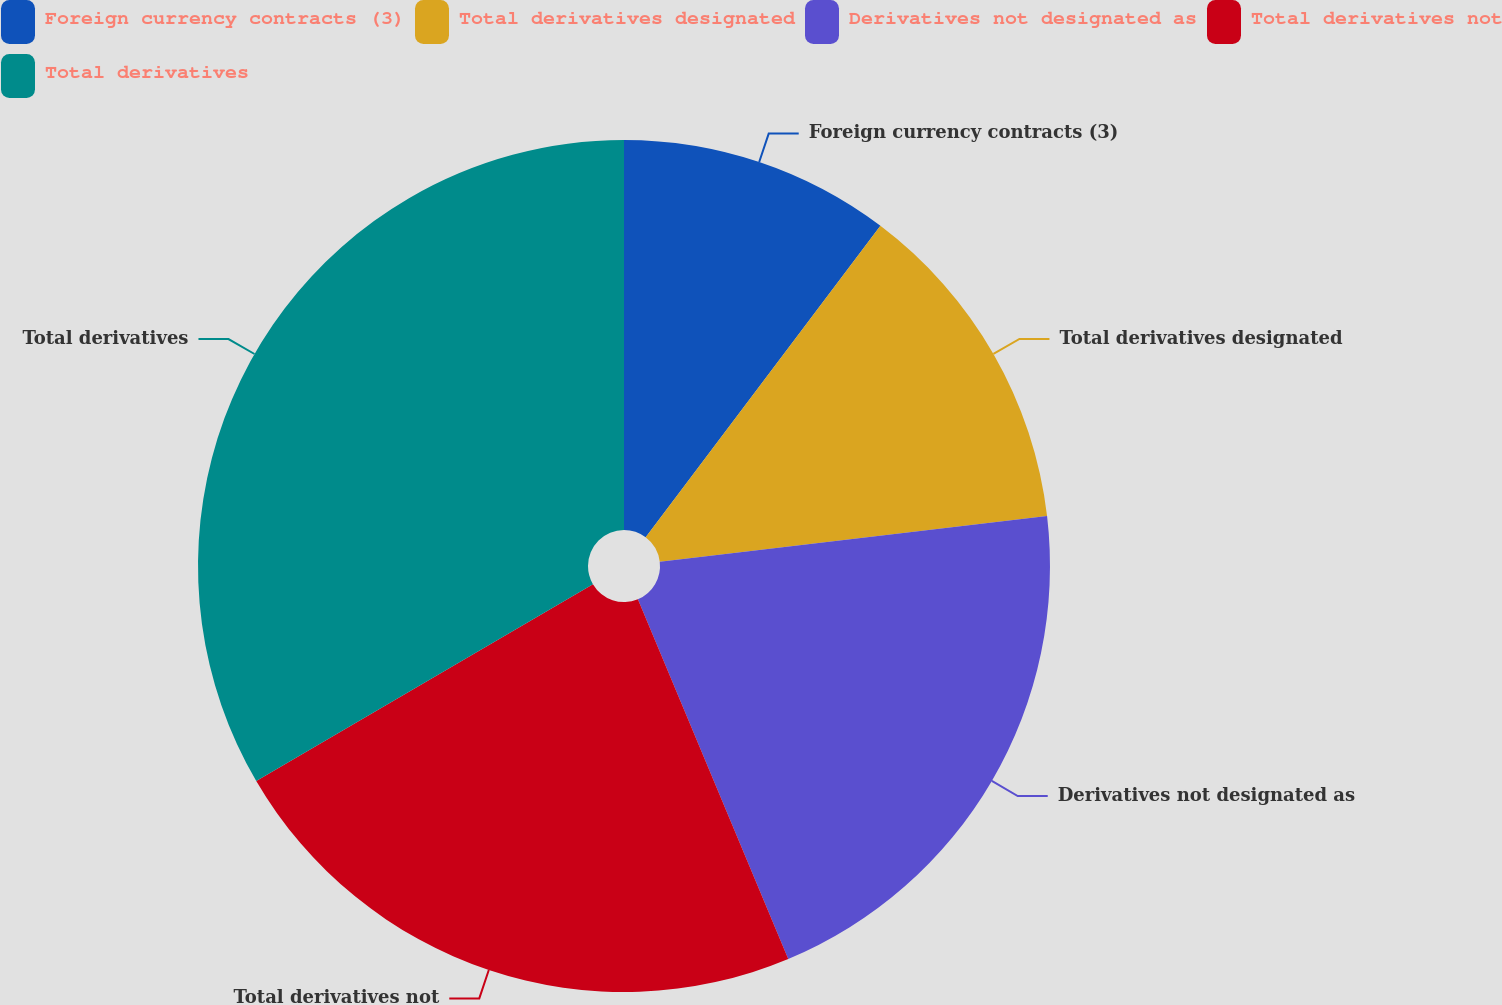Convert chart to OTSL. <chart><loc_0><loc_0><loc_500><loc_500><pie_chart><fcel>Foreign currency contracts (3)<fcel>Total derivatives designated<fcel>Derivatives not designated as<fcel>Total derivatives not<fcel>Total derivatives<nl><fcel>10.28%<fcel>12.85%<fcel>20.57%<fcel>22.88%<fcel>33.42%<nl></chart> 